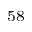Convert formula to latex. <formula><loc_0><loc_0><loc_500><loc_500>^ { 5 8 }</formula> 